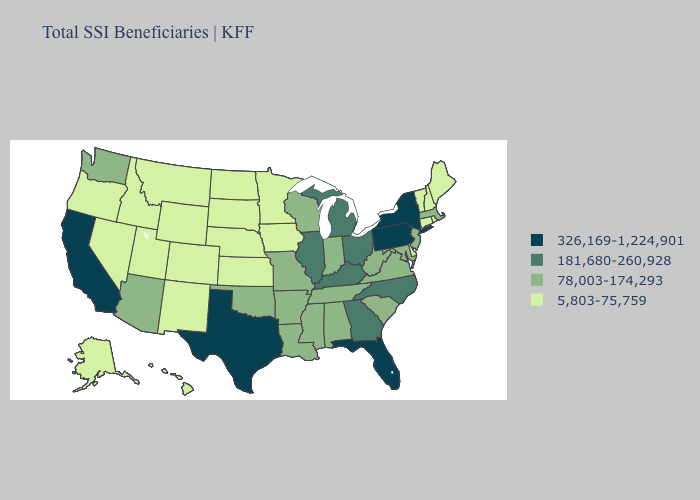Does Oklahoma have the same value as Missouri?
Keep it brief. Yes. Does Iowa have the highest value in the MidWest?
Keep it brief. No. Name the states that have a value in the range 78,003-174,293?
Quick response, please. Alabama, Arizona, Arkansas, Indiana, Louisiana, Maryland, Massachusetts, Mississippi, Missouri, New Jersey, Oklahoma, South Carolina, Tennessee, Virginia, Washington, West Virginia, Wisconsin. What is the value of Nebraska?
Write a very short answer. 5,803-75,759. Among the states that border West Virginia , does Pennsylvania have the highest value?
Short answer required. Yes. What is the value of New Hampshire?
Answer briefly. 5,803-75,759. Name the states that have a value in the range 181,680-260,928?
Be succinct. Georgia, Illinois, Kentucky, Michigan, North Carolina, Ohio. Among the states that border Missouri , which have the highest value?
Keep it brief. Illinois, Kentucky. Does the map have missing data?
Write a very short answer. No. Name the states that have a value in the range 78,003-174,293?
Short answer required. Alabama, Arizona, Arkansas, Indiana, Louisiana, Maryland, Massachusetts, Mississippi, Missouri, New Jersey, Oklahoma, South Carolina, Tennessee, Virginia, Washington, West Virginia, Wisconsin. What is the value of Florida?
Keep it brief. 326,169-1,224,901. Does the first symbol in the legend represent the smallest category?
Answer briefly. No. Name the states that have a value in the range 326,169-1,224,901?
Be succinct. California, Florida, New York, Pennsylvania, Texas. Name the states that have a value in the range 326,169-1,224,901?
Short answer required. California, Florida, New York, Pennsylvania, Texas. Is the legend a continuous bar?
Be succinct. No. 